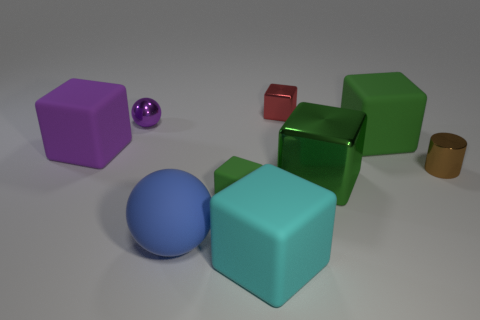How many green blocks must be subtracted to get 1 green blocks? 2 Subtract all small green rubber cubes. How many cubes are left? 5 Subtract all green blocks. How many blocks are left? 3 Subtract 1 cylinders. How many cylinders are left? 0 Add 9 purple rubber things. How many purple rubber things are left? 10 Add 2 big blue objects. How many big blue objects exist? 3 Add 1 red metallic cylinders. How many objects exist? 10 Subtract 0 brown cubes. How many objects are left? 9 Subtract all balls. How many objects are left? 7 Subtract all red blocks. Subtract all green spheres. How many blocks are left? 5 